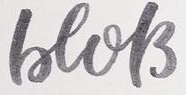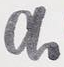What text appears in these images from left to right, separated by a semicolon? beols; a 